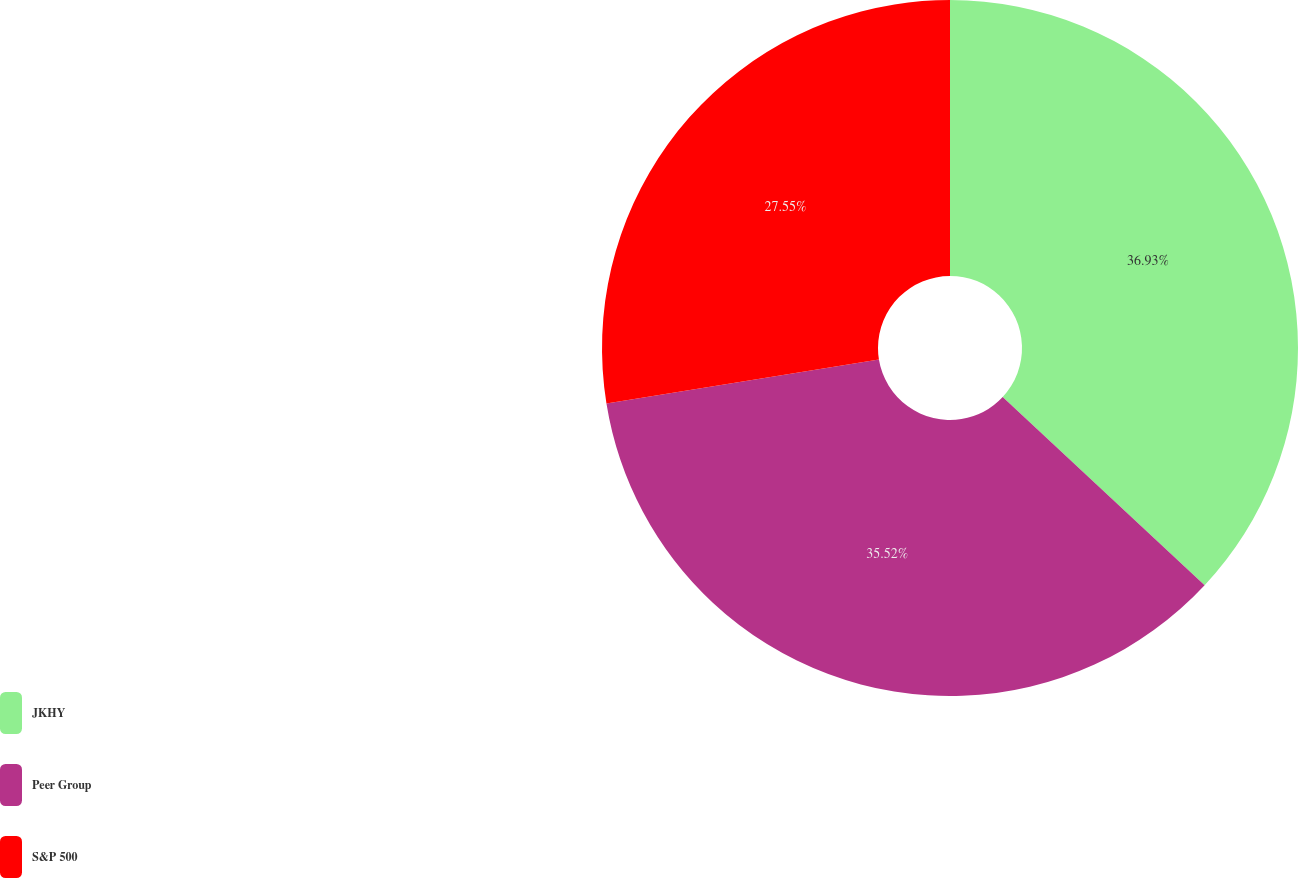Convert chart to OTSL. <chart><loc_0><loc_0><loc_500><loc_500><pie_chart><fcel>JKHY<fcel>Peer Group<fcel>S&P 500<nl><fcel>36.94%<fcel>35.52%<fcel>27.55%<nl></chart> 